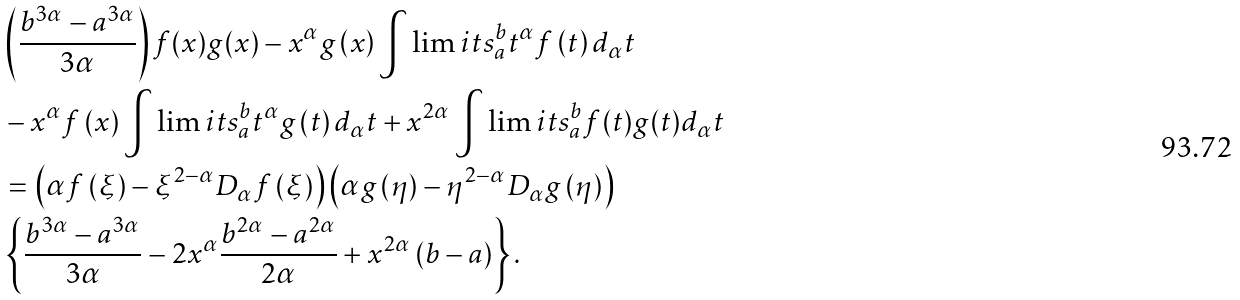<formula> <loc_0><loc_0><loc_500><loc_500>& \left ( { \frac { { b ^ { 3 \alpha } - a ^ { 3 \alpha } } } { 3 \alpha } } \right ) f ( x ) g ( x ) - x ^ { \alpha } g \left ( x \right ) \int \lim i t s _ { a } ^ { b } { t ^ { \alpha } f \left ( t \right ) d _ { \alpha } } t \\ & - x ^ { \alpha } f \left ( x \right ) \int \lim i t s _ { a } ^ { b } { t ^ { \alpha } g \left ( t \right ) d _ { \alpha } } t + x ^ { 2 \alpha } \int \lim i t s _ { a } ^ { b } { f ( t ) g ( t ) } d _ { \alpha } t \\ & = \left ( { \alpha f \left ( \xi \right ) - \xi ^ { 2 - \alpha } D _ { \alpha } f \left ( \xi \right ) } \right ) \left ( { \alpha g \left ( \eta \right ) - \eta ^ { 2 - \alpha } D _ { \alpha } g \left ( \eta \right ) } \right ) \\ & \left \{ { \frac { { b ^ { 3 \alpha } - a ^ { 3 \alpha } } } { 3 \alpha } - 2 x ^ { \alpha } \frac { { b ^ { 2 \alpha } - a ^ { 2 \alpha } } } { 2 \alpha } + x ^ { 2 \alpha } \left ( { b - a } \right ) } \right \} .</formula> 